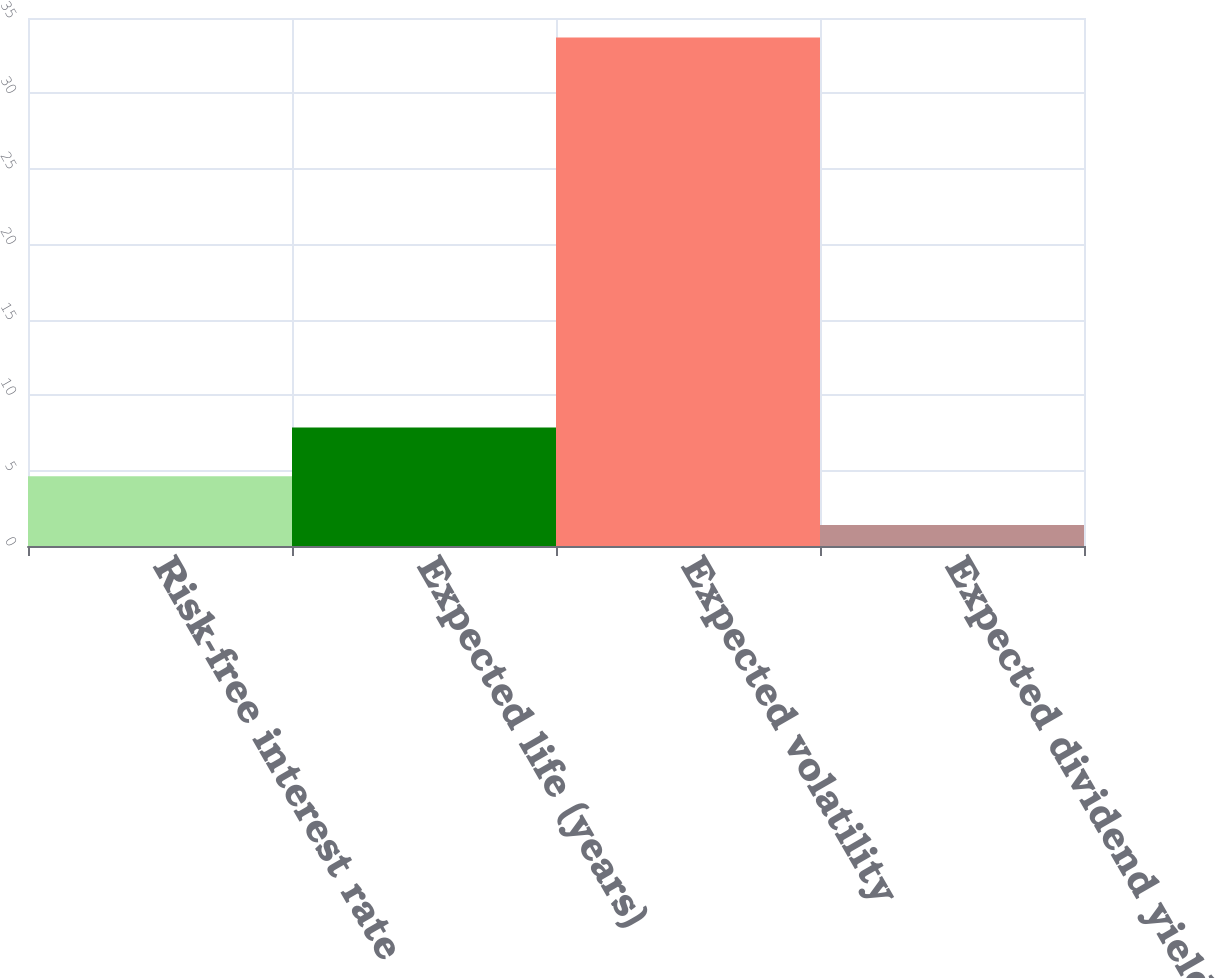Convert chart to OTSL. <chart><loc_0><loc_0><loc_500><loc_500><bar_chart><fcel>Risk-free interest rate<fcel>Expected life (years)<fcel>Expected volatility<fcel>Expected dividend yield<nl><fcel>4.63<fcel>7.86<fcel>33.7<fcel>1.4<nl></chart> 